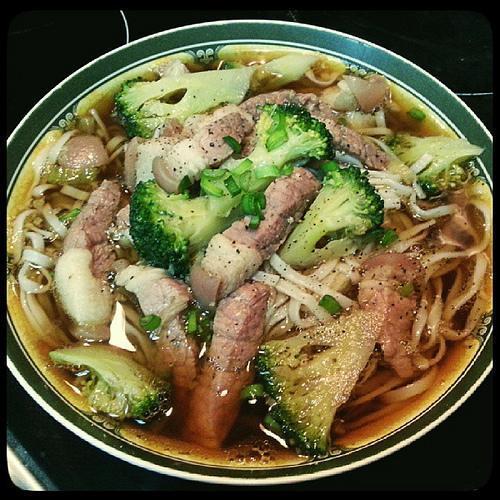How many pieces of food are broccoli?
Give a very brief answer. 7. 